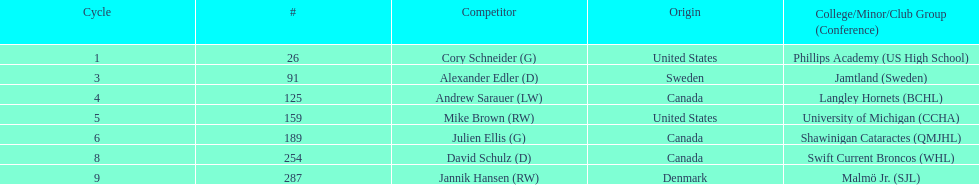How many goalies drafted? 2. 